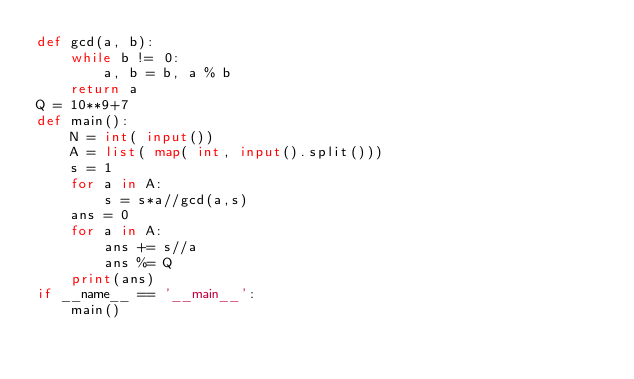<code> <loc_0><loc_0><loc_500><loc_500><_Python_>def gcd(a, b):
    while b != 0:
        a, b = b, a % b
    return a
Q = 10**9+7
def main():
    N = int( input())
    A = list( map( int, input().split()))
    s = 1
    for a in A:
        s = s*a//gcd(a,s)
    ans = 0
    for a in A:
        ans += s//a
        ans %= Q
    print(ans)
if __name__ == '__main__':
    main()
</code> 